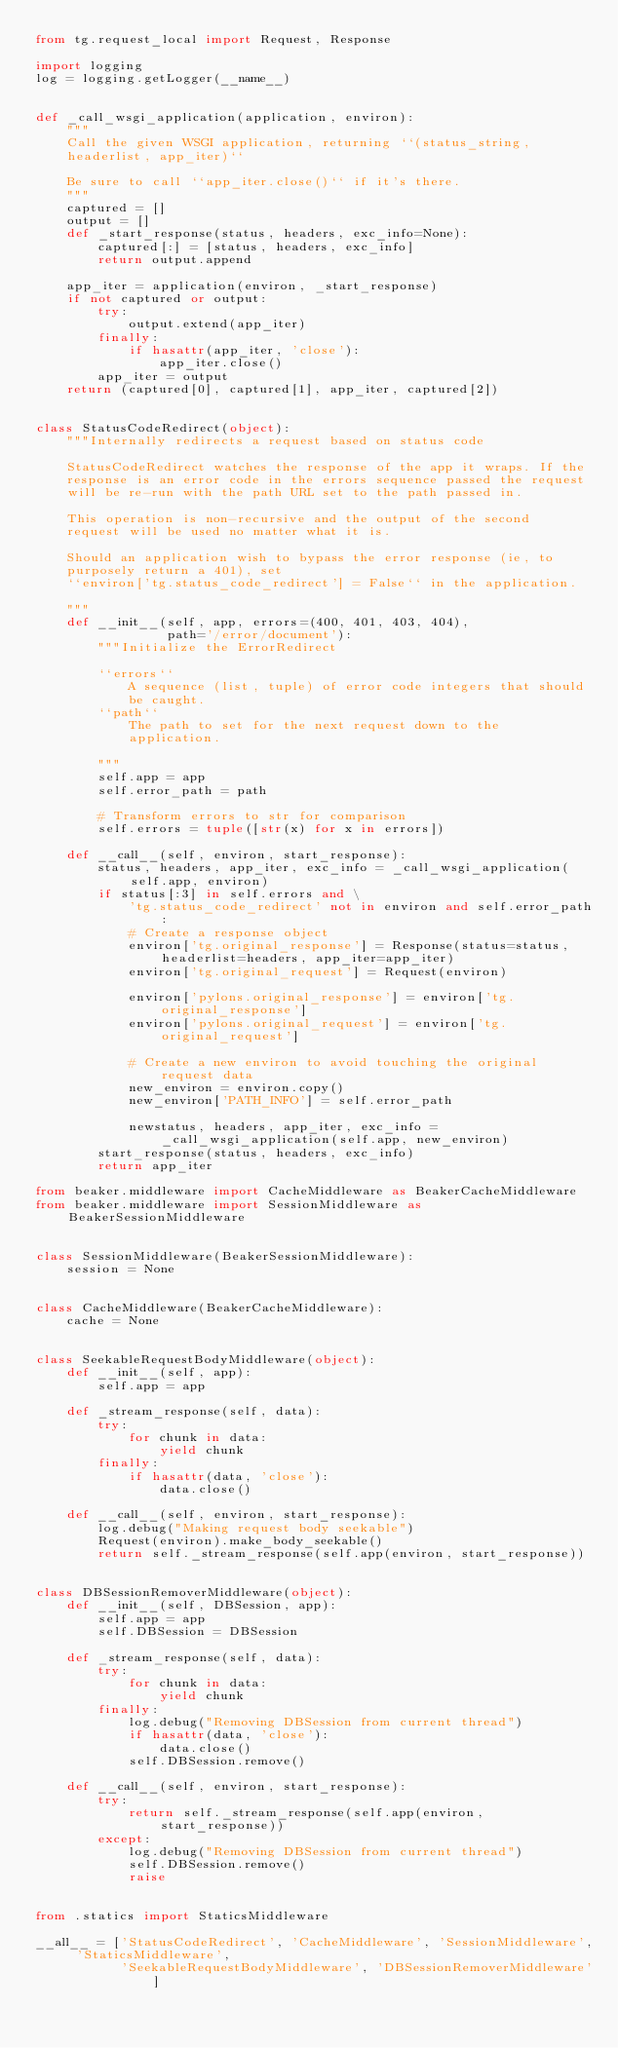Convert code to text. <code><loc_0><loc_0><loc_500><loc_500><_Python_>from tg.request_local import Request, Response

import logging
log = logging.getLogger(__name__)


def _call_wsgi_application(application, environ):
    """
    Call the given WSGI application, returning ``(status_string,
    headerlist, app_iter)``

    Be sure to call ``app_iter.close()`` if it's there.
    """
    captured = []
    output = []
    def _start_response(status, headers, exc_info=None):
        captured[:] = [status, headers, exc_info]
        return output.append

    app_iter = application(environ, _start_response)
    if not captured or output:
        try:
            output.extend(app_iter)
        finally:
            if hasattr(app_iter, 'close'):
                app_iter.close()
        app_iter = output
    return (captured[0], captured[1], app_iter, captured[2])


class StatusCodeRedirect(object):
    """Internally redirects a request based on status code

    StatusCodeRedirect watches the response of the app it wraps. If the
    response is an error code in the errors sequence passed the request
    will be re-run with the path URL set to the path passed in.

    This operation is non-recursive and the output of the second
    request will be used no matter what it is.

    Should an application wish to bypass the error response (ie, to
    purposely return a 401), set
    ``environ['tg.status_code_redirect'] = False`` in the application.

    """
    def __init__(self, app, errors=(400, 401, 403, 404),
                 path='/error/document'):
        """Initialize the ErrorRedirect

        ``errors``
            A sequence (list, tuple) of error code integers that should
            be caught.
        ``path``
            The path to set for the next request down to the
            application.

        """
        self.app = app
        self.error_path = path

        # Transform errors to str for comparison
        self.errors = tuple([str(x) for x in errors])

    def __call__(self, environ, start_response):
        status, headers, app_iter, exc_info = _call_wsgi_application(self.app, environ)
        if status[:3] in self.errors and \
            'tg.status_code_redirect' not in environ and self.error_path:
            # Create a response object
            environ['tg.original_response'] = Response(status=status, headerlist=headers, app_iter=app_iter)
            environ['tg.original_request'] = Request(environ)

            environ['pylons.original_response'] = environ['tg.original_response']
            environ['pylons.original_request'] = environ['tg.original_request']
            
            # Create a new environ to avoid touching the original request data
            new_environ = environ.copy()
            new_environ['PATH_INFO'] = self.error_path

            newstatus, headers, app_iter, exc_info = _call_wsgi_application(self.app, new_environ)
        start_response(status, headers, exc_info)
        return app_iter

from beaker.middleware import CacheMiddleware as BeakerCacheMiddleware
from beaker.middleware import SessionMiddleware as BeakerSessionMiddleware


class SessionMiddleware(BeakerSessionMiddleware):
    session = None


class CacheMiddleware(BeakerCacheMiddleware):
    cache = None


class SeekableRequestBodyMiddleware(object):
    def __init__(self, app):
        self.app = app

    def _stream_response(self, data):
        try:
            for chunk in data:
                yield chunk
        finally:
            if hasattr(data, 'close'):
                data.close()

    def __call__(self, environ, start_response):
        log.debug("Making request body seekable")
        Request(environ).make_body_seekable()
        return self._stream_response(self.app(environ, start_response))


class DBSessionRemoverMiddleware(object):
    def __init__(self, DBSession, app):
        self.app = app
        self.DBSession = DBSession

    def _stream_response(self, data):
        try:
            for chunk in data:
                yield chunk
        finally:
            log.debug("Removing DBSession from current thread")
            if hasattr(data, 'close'):
                data.close()
            self.DBSession.remove()

    def __call__(self, environ, start_response):
        try:
            return self._stream_response(self.app(environ, start_response))
        except:
            log.debug("Removing DBSession from current thread")
            self.DBSession.remove()
            raise


from .statics import StaticsMiddleware

__all__ = ['StatusCodeRedirect', 'CacheMiddleware', 'SessionMiddleware', 'StaticsMiddleware',
           'SeekableRequestBodyMiddleware', 'DBSessionRemoverMiddleware']
</code> 